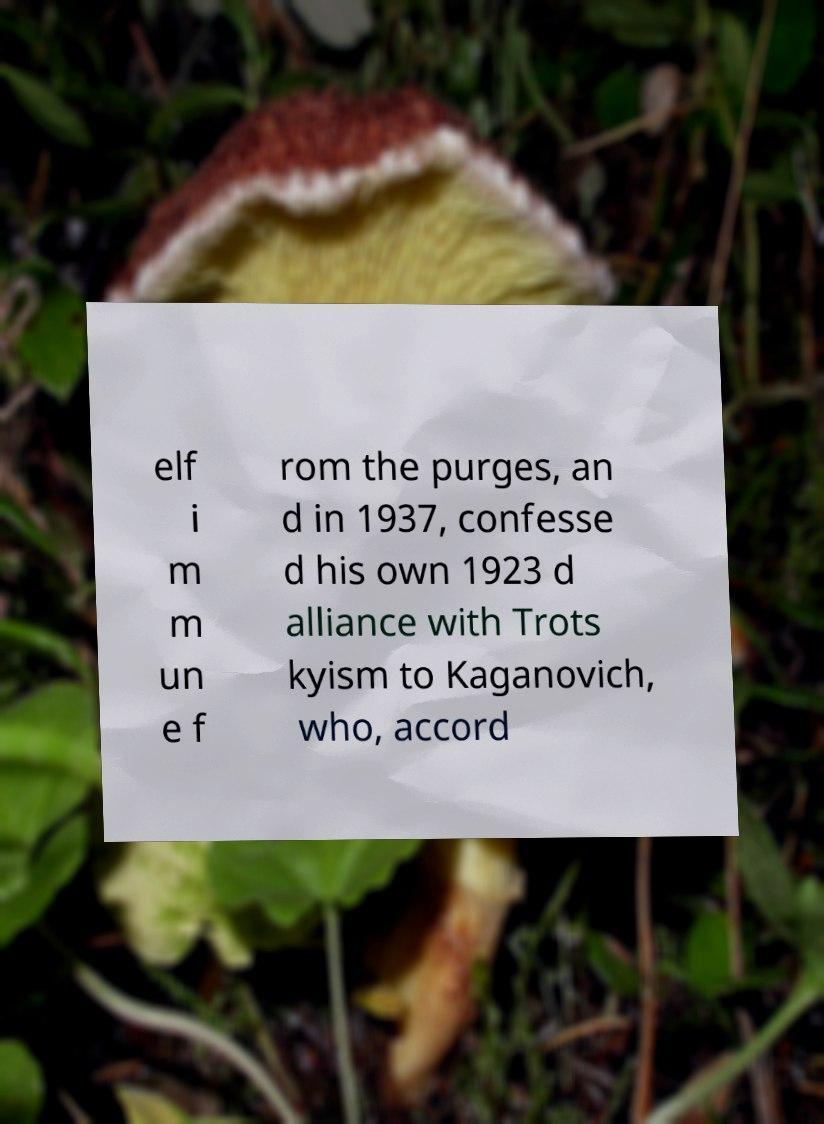Could you extract and type out the text from this image? elf i m m un e f rom the purges, an d in 1937, confesse d his own 1923 d alliance with Trots kyism to Kaganovich, who, accord 